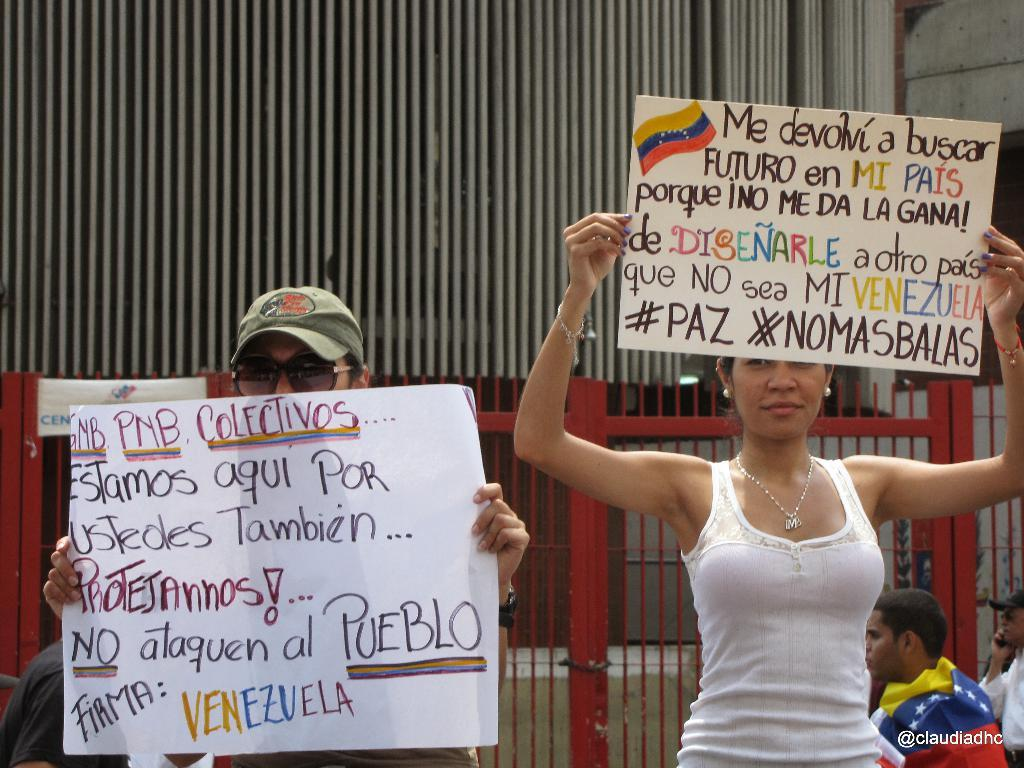What are the two people in the image holding? The two people in the image are holding posters. What can be seen in the background of the image? There are people and grills visible in the background of the image. Is there any text present in the image? Yes, there is some text visible in the bottom right corner of the image. What type of lead is being used to connect the tent to the basin in the image? There is no tent or basin present in the image, so it is not possible to determine what type of lead might be connecting them. 